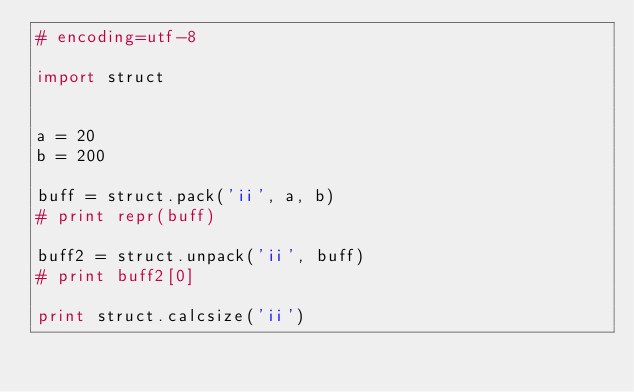Convert code to text. <code><loc_0><loc_0><loc_500><loc_500><_Python_># encoding=utf-8

import struct


a = 20
b = 200

buff = struct.pack('ii', a, b)
# print repr(buff)

buff2 = struct.unpack('ii', buff)
# print buff2[0]

print struct.calcsize('ii')



</code> 